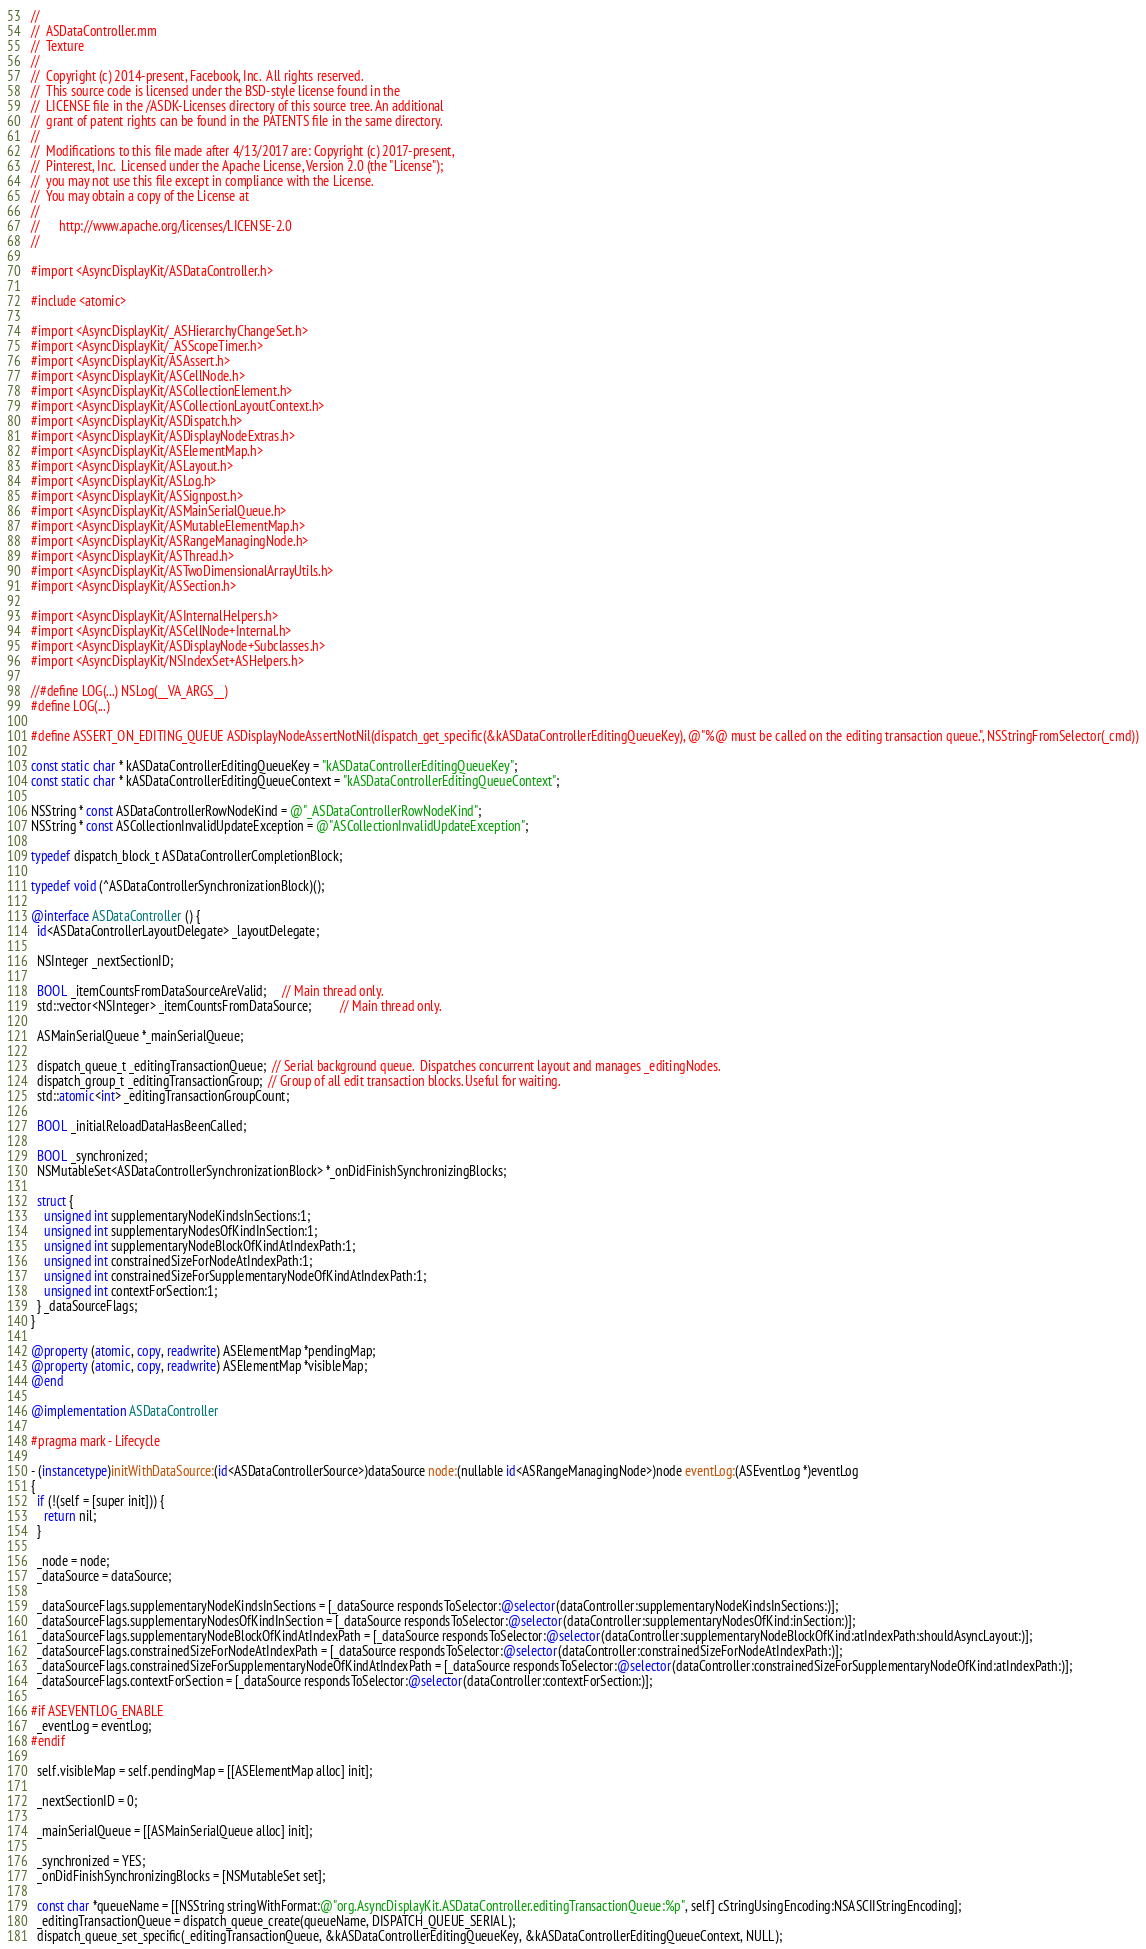<code> <loc_0><loc_0><loc_500><loc_500><_ObjectiveC_>//
//  ASDataController.mm
//  Texture
//
//  Copyright (c) 2014-present, Facebook, Inc.  All rights reserved.
//  This source code is licensed under the BSD-style license found in the
//  LICENSE file in the /ASDK-Licenses directory of this source tree. An additional
//  grant of patent rights can be found in the PATENTS file in the same directory.
//
//  Modifications to this file made after 4/13/2017 are: Copyright (c) 2017-present,
//  Pinterest, Inc.  Licensed under the Apache License, Version 2.0 (the "License");
//  you may not use this file except in compliance with the License.
//  You may obtain a copy of the License at
//
//      http://www.apache.org/licenses/LICENSE-2.0
//

#import <AsyncDisplayKit/ASDataController.h>

#include <atomic>

#import <AsyncDisplayKit/_ASHierarchyChangeSet.h>
#import <AsyncDisplayKit/_ASScopeTimer.h>
#import <AsyncDisplayKit/ASAssert.h>
#import <AsyncDisplayKit/ASCellNode.h>
#import <AsyncDisplayKit/ASCollectionElement.h>
#import <AsyncDisplayKit/ASCollectionLayoutContext.h>
#import <AsyncDisplayKit/ASDispatch.h>
#import <AsyncDisplayKit/ASDisplayNodeExtras.h>
#import <AsyncDisplayKit/ASElementMap.h>
#import <AsyncDisplayKit/ASLayout.h>
#import <AsyncDisplayKit/ASLog.h>
#import <AsyncDisplayKit/ASSignpost.h>
#import <AsyncDisplayKit/ASMainSerialQueue.h>
#import <AsyncDisplayKit/ASMutableElementMap.h>
#import <AsyncDisplayKit/ASRangeManagingNode.h>
#import <AsyncDisplayKit/ASThread.h>
#import <AsyncDisplayKit/ASTwoDimensionalArrayUtils.h>
#import <AsyncDisplayKit/ASSection.h>

#import <AsyncDisplayKit/ASInternalHelpers.h>
#import <AsyncDisplayKit/ASCellNode+Internal.h>
#import <AsyncDisplayKit/ASDisplayNode+Subclasses.h>
#import <AsyncDisplayKit/NSIndexSet+ASHelpers.h>

//#define LOG(...) NSLog(__VA_ARGS__)
#define LOG(...)

#define ASSERT_ON_EDITING_QUEUE ASDisplayNodeAssertNotNil(dispatch_get_specific(&kASDataControllerEditingQueueKey), @"%@ must be called on the editing transaction queue.", NSStringFromSelector(_cmd))

const static char * kASDataControllerEditingQueueKey = "kASDataControllerEditingQueueKey";
const static char * kASDataControllerEditingQueueContext = "kASDataControllerEditingQueueContext";

NSString * const ASDataControllerRowNodeKind = @"_ASDataControllerRowNodeKind";
NSString * const ASCollectionInvalidUpdateException = @"ASCollectionInvalidUpdateException";

typedef dispatch_block_t ASDataControllerCompletionBlock;

typedef void (^ASDataControllerSynchronizationBlock)();

@interface ASDataController () {
  id<ASDataControllerLayoutDelegate> _layoutDelegate;

  NSInteger _nextSectionID;
  
  BOOL _itemCountsFromDataSourceAreValid;     // Main thread only.
  std::vector<NSInteger> _itemCountsFromDataSource;         // Main thread only.
  
  ASMainSerialQueue *_mainSerialQueue;

  dispatch_queue_t _editingTransactionQueue;  // Serial background queue.  Dispatches concurrent layout and manages _editingNodes.
  dispatch_group_t _editingTransactionGroup;  // Group of all edit transaction blocks. Useful for waiting.
  std::atomic<int> _editingTransactionGroupCount;
  
  BOOL _initialReloadDataHasBeenCalled;

  BOOL _synchronized;
  NSMutableSet<ASDataControllerSynchronizationBlock> *_onDidFinishSynchronizingBlocks;

  struct {
    unsigned int supplementaryNodeKindsInSections:1;
    unsigned int supplementaryNodesOfKindInSection:1;
    unsigned int supplementaryNodeBlockOfKindAtIndexPath:1;
    unsigned int constrainedSizeForNodeAtIndexPath:1;
    unsigned int constrainedSizeForSupplementaryNodeOfKindAtIndexPath:1;
    unsigned int contextForSection:1;
  } _dataSourceFlags;
}

@property (atomic, copy, readwrite) ASElementMap *pendingMap;
@property (atomic, copy, readwrite) ASElementMap *visibleMap;
@end

@implementation ASDataController

#pragma mark - Lifecycle

- (instancetype)initWithDataSource:(id<ASDataControllerSource>)dataSource node:(nullable id<ASRangeManagingNode>)node eventLog:(ASEventLog *)eventLog
{
  if (!(self = [super init])) {
    return nil;
  }
  
  _node = node;
  _dataSource = dataSource;
  
  _dataSourceFlags.supplementaryNodeKindsInSections = [_dataSource respondsToSelector:@selector(dataController:supplementaryNodeKindsInSections:)];
  _dataSourceFlags.supplementaryNodesOfKindInSection = [_dataSource respondsToSelector:@selector(dataController:supplementaryNodesOfKind:inSection:)];
  _dataSourceFlags.supplementaryNodeBlockOfKindAtIndexPath = [_dataSource respondsToSelector:@selector(dataController:supplementaryNodeBlockOfKind:atIndexPath:shouldAsyncLayout:)];
  _dataSourceFlags.constrainedSizeForNodeAtIndexPath = [_dataSource respondsToSelector:@selector(dataController:constrainedSizeForNodeAtIndexPath:)];
  _dataSourceFlags.constrainedSizeForSupplementaryNodeOfKindAtIndexPath = [_dataSource respondsToSelector:@selector(dataController:constrainedSizeForSupplementaryNodeOfKind:atIndexPath:)];
  _dataSourceFlags.contextForSection = [_dataSource respondsToSelector:@selector(dataController:contextForSection:)];
  
#if ASEVENTLOG_ENABLE
  _eventLog = eventLog;
#endif

  self.visibleMap = self.pendingMap = [[ASElementMap alloc] init];
  
  _nextSectionID = 0;
  
  _mainSerialQueue = [[ASMainSerialQueue alloc] init];

  _synchronized = YES;
  _onDidFinishSynchronizingBlocks = [NSMutableSet set];
  
  const char *queueName = [[NSString stringWithFormat:@"org.AsyncDisplayKit.ASDataController.editingTransactionQueue:%p", self] cStringUsingEncoding:NSASCIIStringEncoding];
  _editingTransactionQueue = dispatch_queue_create(queueName, DISPATCH_QUEUE_SERIAL);
  dispatch_queue_set_specific(_editingTransactionQueue, &kASDataControllerEditingQueueKey, &kASDataControllerEditingQueueContext, NULL);</code> 